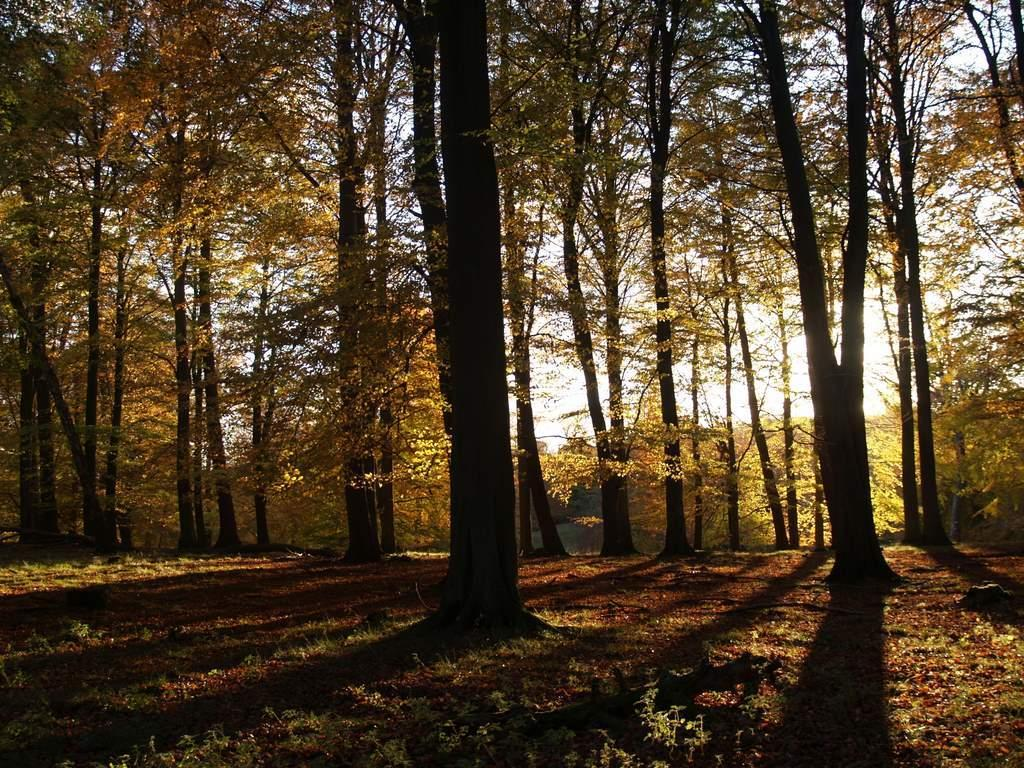What is the primary element visible in the image? The image contains the sky. What can be seen in the sky? Clouds are present in the image. What type of vegetation is visible in the image? There are trees and plants visible in the image. What is the ground covered with in the image? Grass is present in the image. How many faces can be seen in the image? There are no faces present in the image. Are there any brothers depicted in the image? There is no reference to any brothers in the image. 